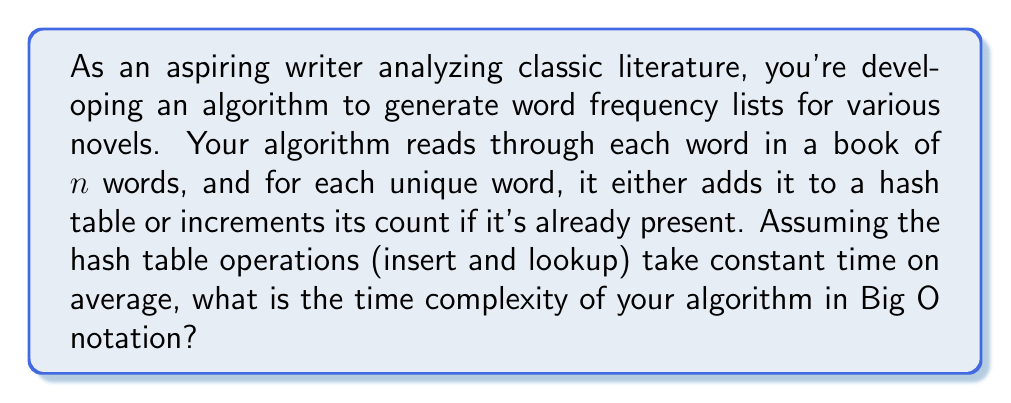Can you answer this question? Let's break down the algorithm and analyze its runtime:

1. The algorithm iterates through each word in the book once. This takes $O(n)$ time, where $n$ is the number of words in the book.

2. For each word, the algorithm performs two operations:
   a. A lookup in the hash table to check if the word exists.
   b. Either an insert (if it's a new word) or an increment (if it's already in the table).

3. Both hash table operations (lookup and insert/increment) are assumed to take constant time on average, i.e., $O(1)$.

4. These operations are performed for each of the $n$ words in the book.

Therefore, the total time complexity can be calculated as follows:

$$T(n) = n \times (O(1) + O(1)) = n \times O(1) = O(n)$$

The algorithm performs a constant amount of work for each word, and it does this for all $n$ words in the book. This results in a linear time complexity.

It's worth noting that while the space complexity isn't asked for in this question, it would be $O(u)$, where $u$ is the number of unique words in the book, as the hash table stores each unique word once.
Answer: $O(n)$, where $n$ is the number of words in the book. 